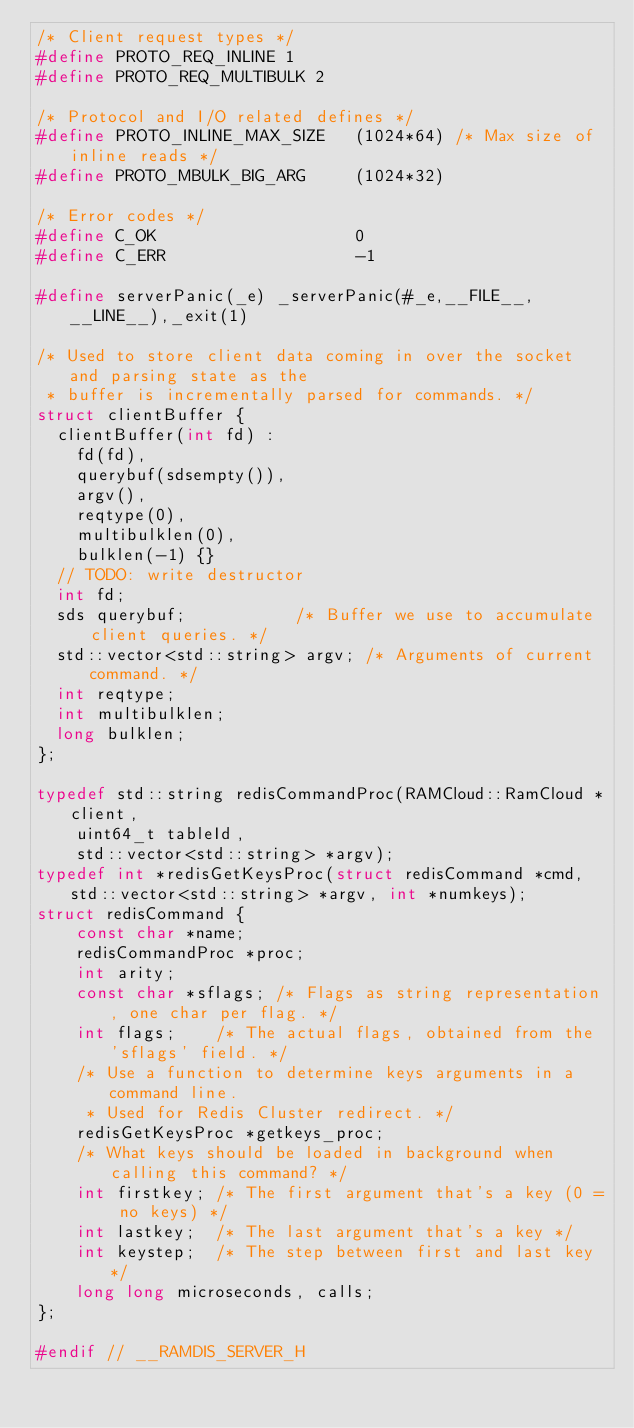<code> <loc_0><loc_0><loc_500><loc_500><_C_>/* Client request types */
#define PROTO_REQ_INLINE 1
#define PROTO_REQ_MULTIBULK 2

/* Protocol and I/O related defines */
#define PROTO_INLINE_MAX_SIZE   (1024*64) /* Max size of inline reads */
#define PROTO_MBULK_BIG_ARG     (1024*32)

/* Error codes */
#define C_OK                    0
#define C_ERR                   -1

#define serverPanic(_e) _serverPanic(#_e,__FILE__,__LINE__),_exit(1)

/* Used to store client data coming in over the socket and parsing state as the
 * buffer is incrementally parsed for commands. */
struct clientBuffer {
  clientBuffer(int fd) : 
    fd(fd),
    querybuf(sdsempty()),
    argv(),
    reqtype(0),
    multibulklen(0),
    bulklen(-1) {}
  // TODO: write destructor
  int fd;
  sds querybuf;           /* Buffer we use to accumulate client queries. */
  std::vector<std::string> argv; /* Arguments of current command. */
  int reqtype;
  int multibulklen;
  long bulklen;
};

typedef std::string redisCommandProc(RAMCloud::RamCloud *client, 
    uint64_t tableId,
    std::vector<std::string> *argv);
typedef int *redisGetKeysProc(struct redisCommand *cmd, std::vector<std::string> *argv, int *numkeys);
struct redisCommand {
    const char *name;
    redisCommandProc *proc;
    int arity;
    const char *sflags; /* Flags as string representation, one char per flag. */
    int flags;    /* The actual flags, obtained from the 'sflags' field. */
    /* Use a function to determine keys arguments in a command line.
     * Used for Redis Cluster redirect. */
    redisGetKeysProc *getkeys_proc;
    /* What keys should be loaded in background when calling this command? */
    int firstkey; /* The first argument that's a key (0 = no keys) */
    int lastkey;  /* The last argument that's a key */
    int keystep;  /* The step between first and last key */
    long long microseconds, calls;
};

#endif // __RAMDIS_SERVER_H
</code> 